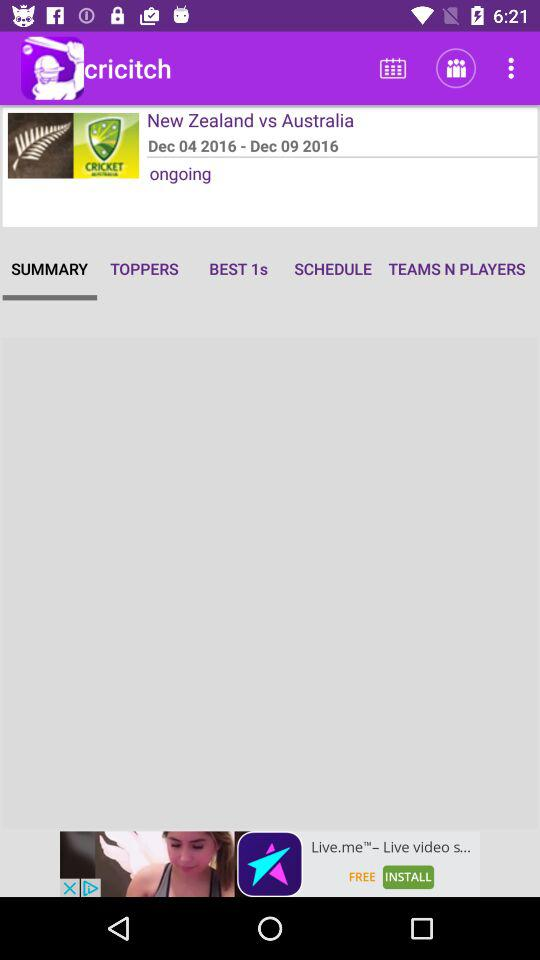The match is between which teams? The match is between the teams "New Zealand" and "Australia". 